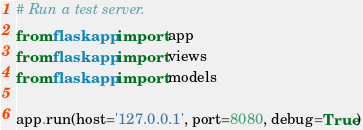<code> <loc_0><loc_0><loc_500><loc_500><_Python_># Run a test server.
from flaskapp import app
from flaskapp import views
from flaskapp import models

app.run(host='127.0.0.1', port=8080, debug=True)
</code> 